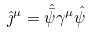<formula> <loc_0><loc_0><loc_500><loc_500>\hat { \jmath } ^ { \mu } = \hat { \bar { \psi } } \gamma ^ { \mu } \hat { \psi }</formula> 